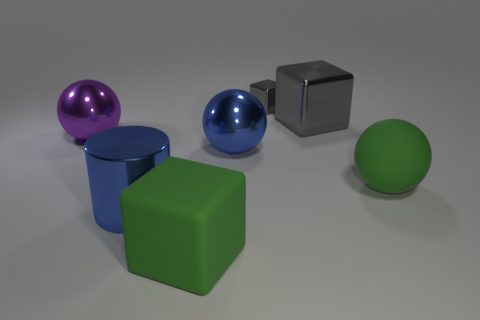Subtract all purple metallic balls. How many balls are left? 2 Subtract all green cylinders. How many gray blocks are left? 2 Add 2 gray cubes. How many objects exist? 9 Subtract all spheres. How many objects are left? 4 Subtract all yellow cubes. Subtract all red balls. How many cubes are left? 3 Add 4 tiny shiny things. How many tiny shiny things are left? 5 Add 2 large green cylinders. How many large green cylinders exist? 2 Subtract 0 blue cubes. How many objects are left? 7 Subtract all metal spheres. Subtract all large red rubber balls. How many objects are left? 5 